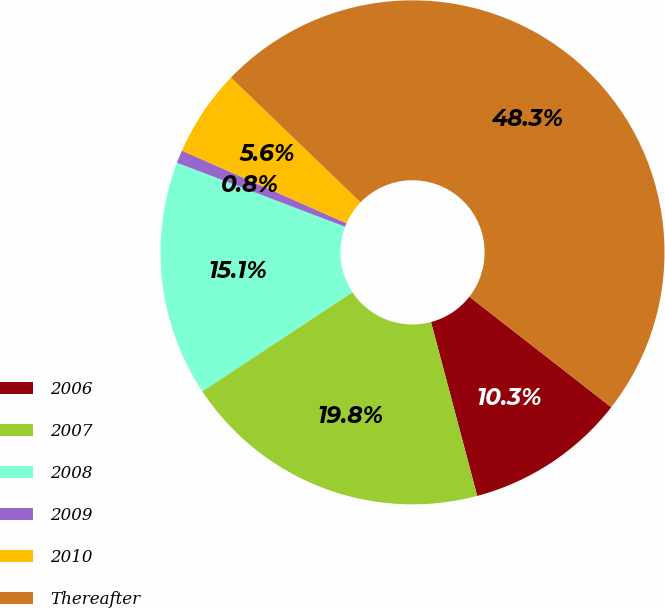<chart> <loc_0><loc_0><loc_500><loc_500><pie_chart><fcel>2006<fcel>2007<fcel>2008<fcel>2009<fcel>2010<fcel>Thereafter<nl><fcel>10.33%<fcel>19.83%<fcel>15.08%<fcel>0.83%<fcel>5.58%<fcel>48.33%<nl></chart> 